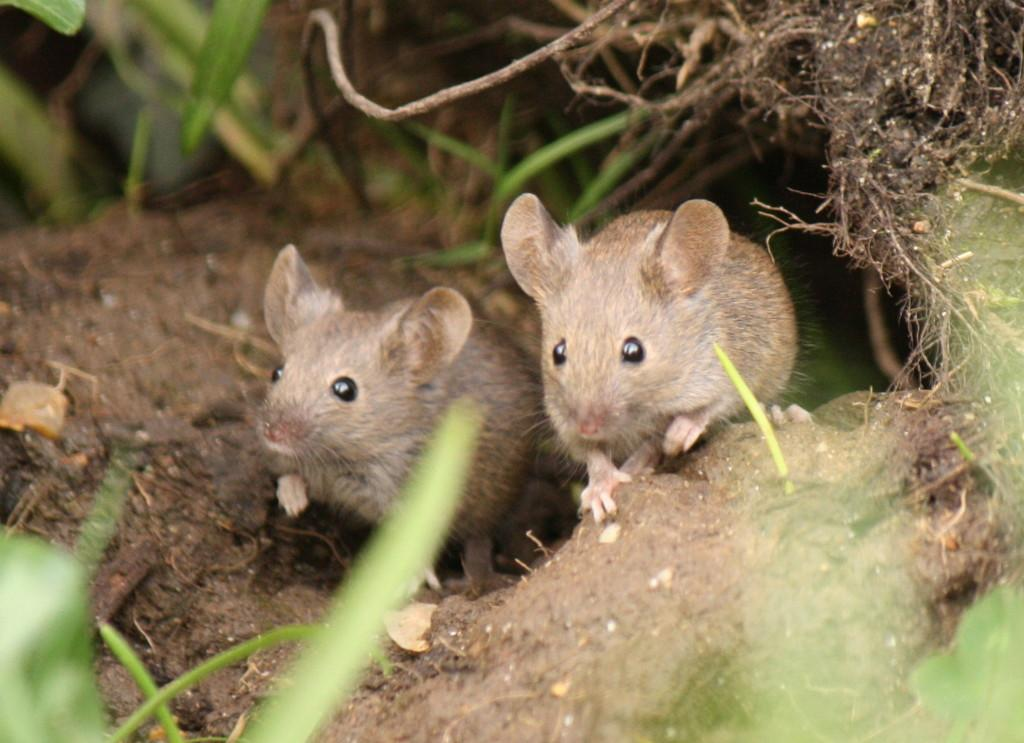What animals are present in the image? There are two mice in the image. Where are the mice located? The mice are on the ground. What type of vegetation can be seen in the image? There are leaves visible in the image. What type of frame surrounds the mice in the image? There is no frame present in the image; it is a photograph or illustration of the mice on the ground. Can you describe the cave where the mice are hiding in the image? There is no cave present in the image; the mice are on the ground, and no structures are visible. 